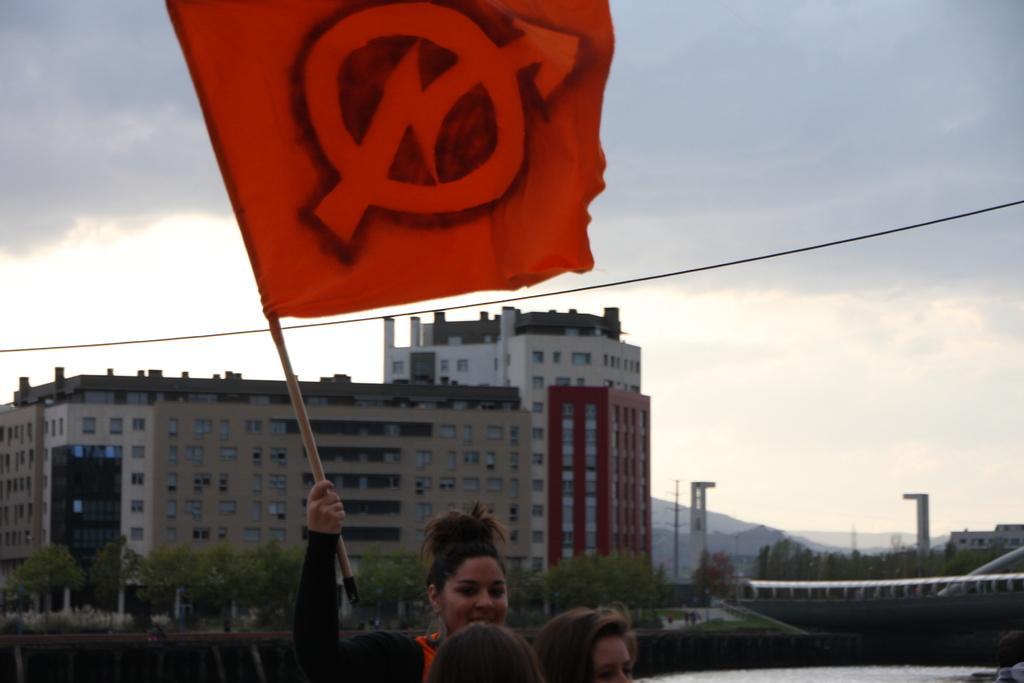Can you describe this image briefly? In this image at the bottom there are three person, one woman holding a flag, behind it there is an object, in the middle there are buildings, trees, poles, visible, at the top there is the sky. 